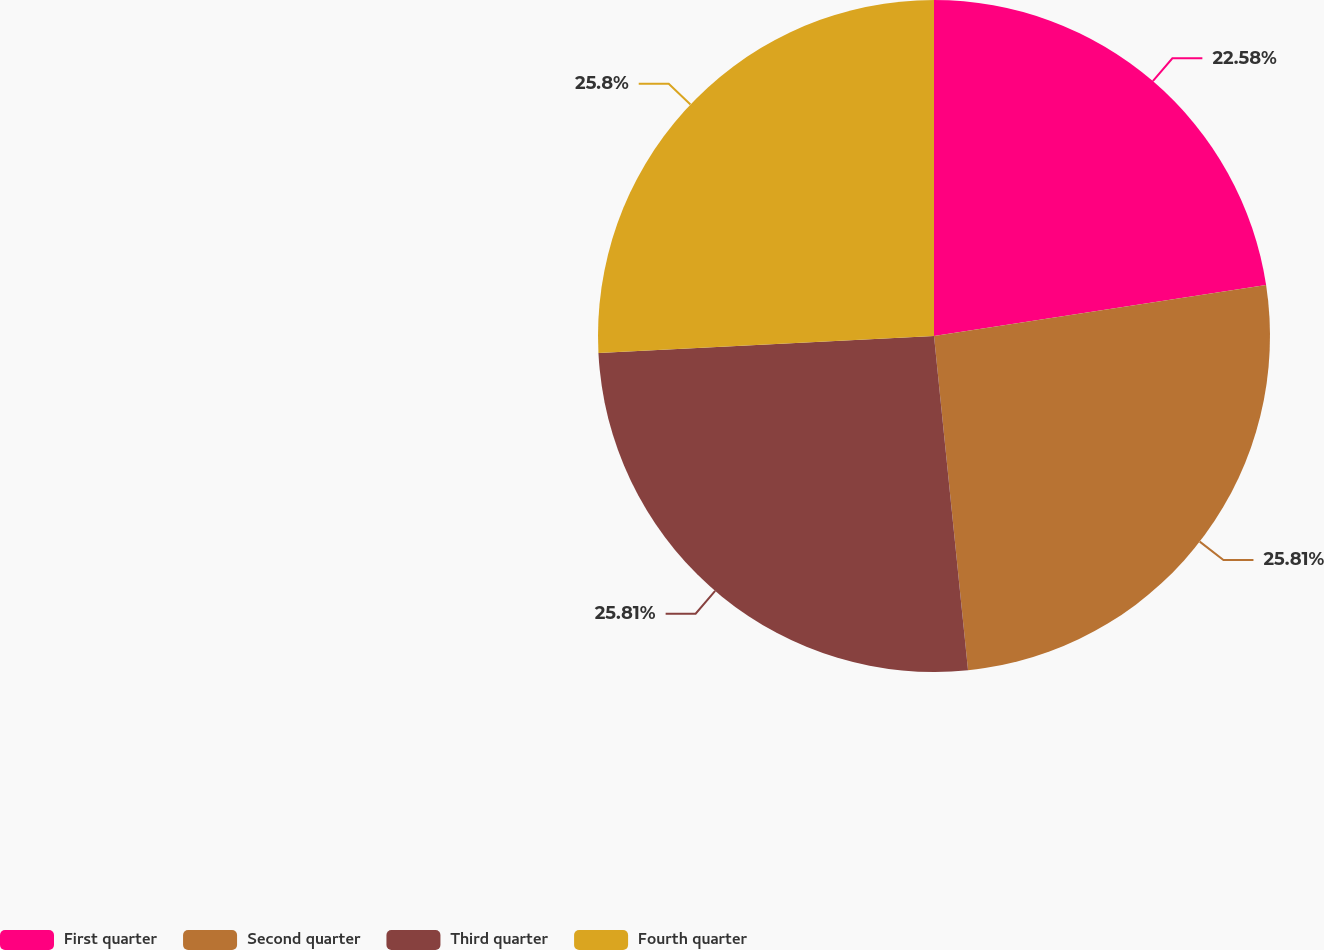Convert chart. <chart><loc_0><loc_0><loc_500><loc_500><pie_chart><fcel>First quarter<fcel>Second quarter<fcel>Third quarter<fcel>Fourth quarter<nl><fcel>22.58%<fcel>25.81%<fcel>25.81%<fcel>25.81%<nl></chart> 